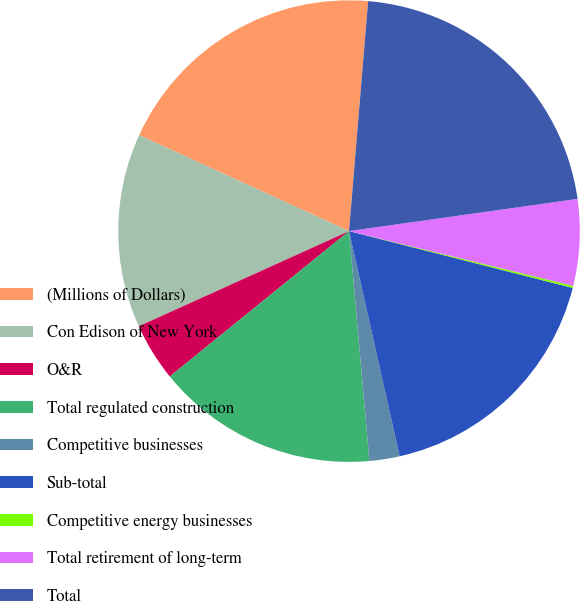<chart> <loc_0><loc_0><loc_500><loc_500><pie_chart><fcel>(Millions of Dollars)<fcel>Con Edison of New York<fcel>O&R<fcel>Total regulated construction<fcel>Competitive businesses<fcel>Sub-total<fcel>Competitive energy businesses<fcel>Total retirement of long-term<fcel>Total<nl><fcel>19.49%<fcel>13.59%<fcel>4.08%<fcel>15.56%<fcel>2.11%<fcel>17.52%<fcel>0.15%<fcel>6.04%<fcel>21.45%<nl></chart> 